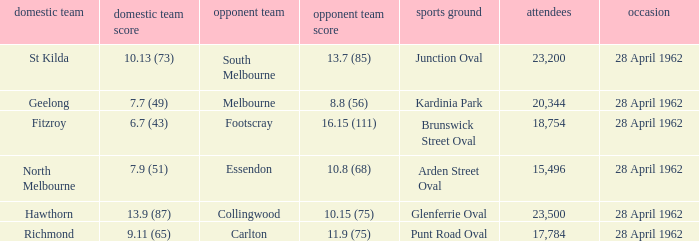At what venue did an away team score 10.15 (75)? Glenferrie Oval. 